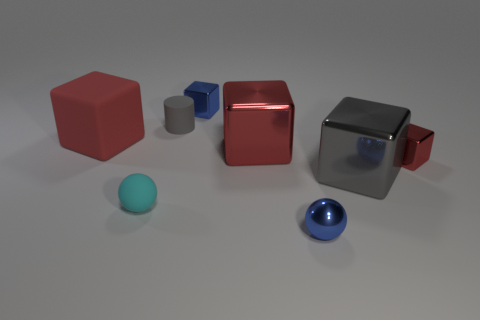How many objects are there, and can you describe their colors and shapes? There are seven objects in total. Starting from the left, there is a large red cube, a small gray cylinder, a small blue cube, a medium-sized red cube with a shiny surface, a large gray cube with a reflective surface, a small blue sphere, and a cyan sphere. 